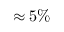Convert formula to latex. <formula><loc_0><loc_0><loc_500><loc_500>\approx 5 \%</formula> 